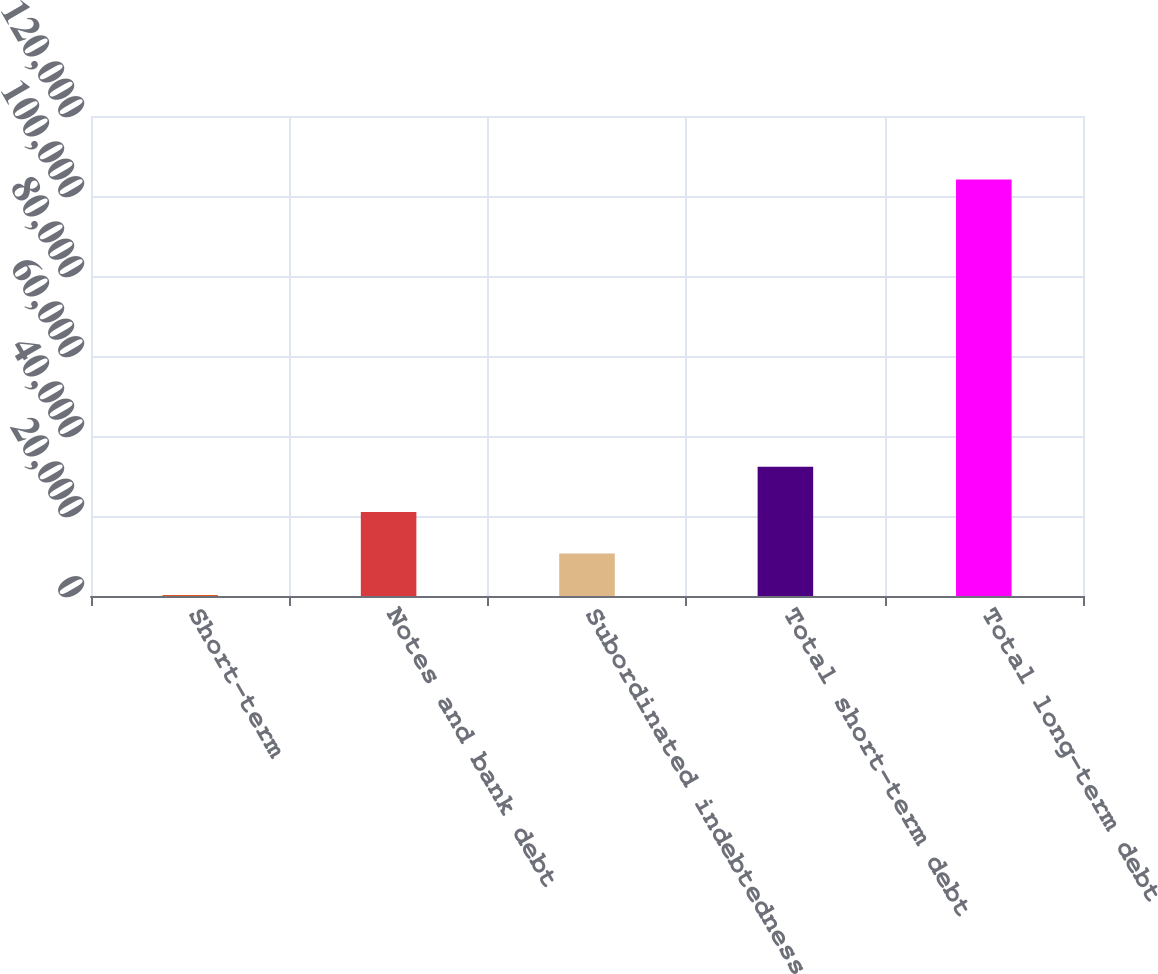Convert chart. <chart><loc_0><loc_0><loc_500><loc_500><bar_chart><fcel>Short-term<fcel>Notes and bank debt<fcel>Subordinated indebtedness<fcel>Total short-term debt<fcel>Total long-term debt<nl><fcel>251<fcel>21024.6<fcel>10637.8<fcel>32335<fcel>104119<nl></chart> 